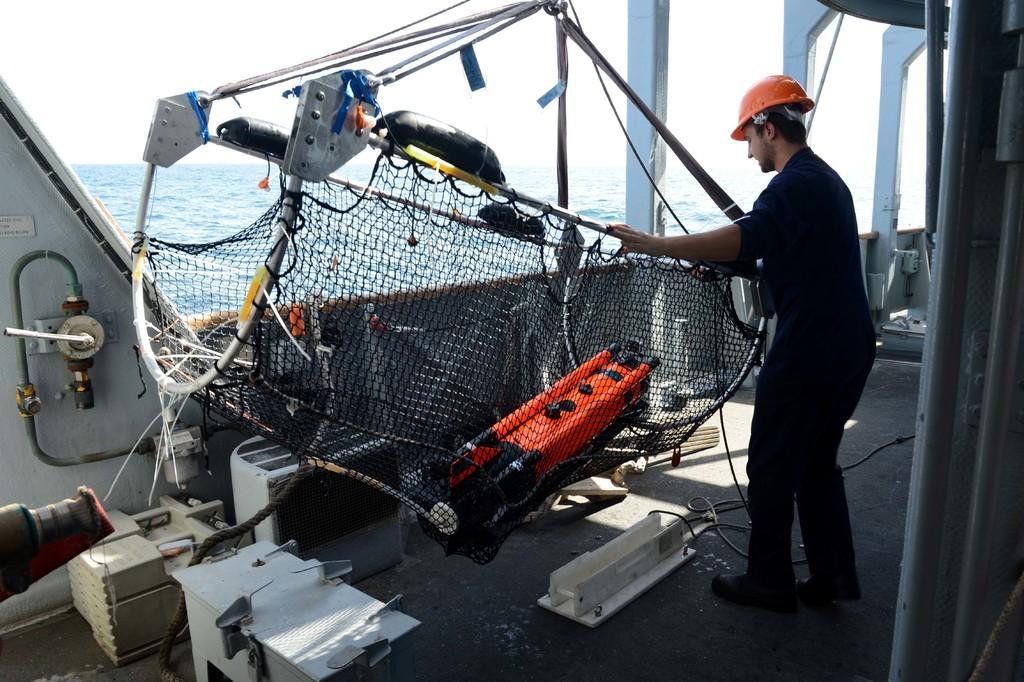In one or two sentences, can you explain what this image depicts? In this image I can see a man is standing in a boat holding an object connected to a net in his hands. I can see a device on the net. I can see some metal objects on the left hand side of the image I can see the sea. I can see the sky at the top of the image. 